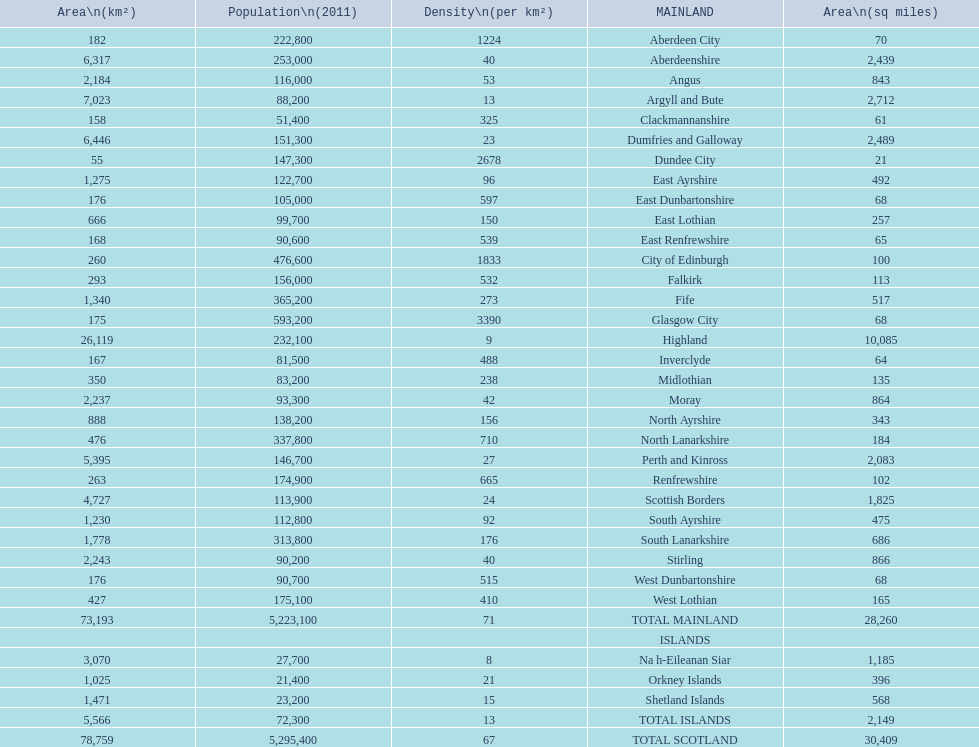What is the difference in square miles from angus and fife? 326. 